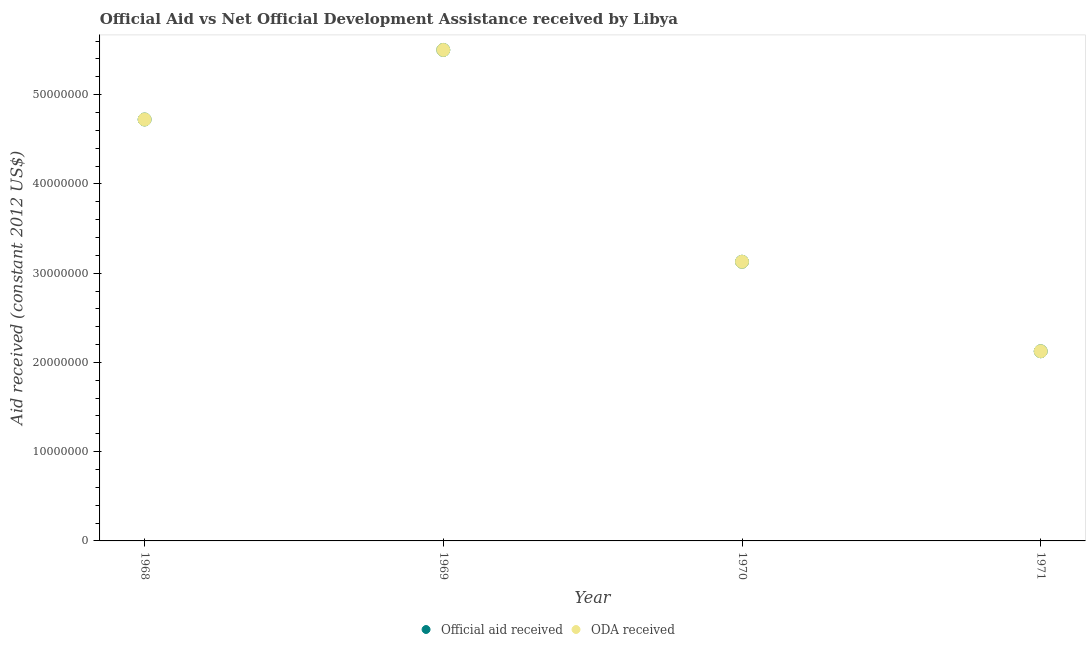How many different coloured dotlines are there?
Your answer should be very brief. 2. What is the official aid received in 1969?
Provide a short and direct response. 5.50e+07. Across all years, what is the maximum official aid received?
Make the answer very short. 5.50e+07. Across all years, what is the minimum official aid received?
Ensure brevity in your answer.  2.12e+07. In which year was the official aid received maximum?
Your response must be concise. 1969. What is the total official aid received in the graph?
Keep it short and to the point. 1.55e+08. What is the difference between the official aid received in 1969 and that in 1970?
Make the answer very short. 2.37e+07. What is the difference between the official aid received in 1968 and the oda received in 1971?
Give a very brief answer. 2.60e+07. What is the average oda received per year?
Provide a short and direct response. 3.87e+07. In the year 1968, what is the difference between the oda received and official aid received?
Offer a terse response. 0. What is the ratio of the oda received in 1968 to that in 1969?
Make the answer very short. 0.86. What is the difference between the highest and the second highest official aid received?
Offer a very short reply. 7.79e+06. What is the difference between the highest and the lowest oda received?
Provide a succinct answer. 3.38e+07. Is the sum of the official aid received in 1970 and 1971 greater than the maximum oda received across all years?
Provide a succinct answer. No. Is the official aid received strictly greater than the oda received over the years?
Offer a terse response. No. How many dotlines are there?
Keep it short and to the point. 2. Does the graph contain any zero values?
Offer a terse response. No. Where does the legend appear in the graph?
Keep it short and to the point. Bottom center. What is the title of the graph?
Offer a very short reply. Official Aid vs Net Official Development Assistance received by Libya . Does "Pregnant women" appear as one of the legend labels in the graph?
Your answer should be compact. No. What is the label or title of the Y-axis?
Provide a short and direct response. Aid received (constant 2012 US$). What is the Aid received (constant 2012 US$) in Official aid received in 1968?
Give a very brief answer. 4.72e+07. What is the Aid received (constant 2012 US$) of ODA received in 1968?
Offer a terse response. 4.72e+07. What is the Aid received (constant 2012 US$) in Official aid received in 1969?
Provide a short and direct response. 5.50e+07. What is the Aid received (constant 2012 US$) in ODA received in 1969?
Keep it short and to the point. 5.50e+07. What is the Aid received (constant 2012 US$) of Official aid received in 1970?
Provide a succinct answer. 3.13e+07. What is the Aid received (constant 2012 US$) in ODA received in 1970?
Your response must be concise. 3.13e+07. What is the Aid received (constant 2012 US$) in Official aid received in 1971?
Offer a very short reply. 2.12e+07. What is the Aid received (constant 2012 US$) of ODA received in 1971?
Your answer should be compact. 2.12e+07. Across all years, what is the maximum Aid received (constant 2012 US$) in Official aid received?
Your response must be concise. 5.50e+07. Across all years, what is the maximum Aid received (constant 2012 US$) of ODA received?
Make the answer very short. 5.50e+07. Across all years, what is the minimum Aid received (constant 2012 US$) of Official aid received?
Offer a very short reply. 2.12e+07. Across all years, what is the minimum Aid received (constant 2012 US$) of ODA received?
Offer a very short reply. 2.12e+07. What is the total Aid received (constant 2012 US$) of Official aid received in the graph?
Provide a succinct answer. 1.55e+08. What is the total Aid received (constant 2012 US$) of ODA received in the graph?
Your answer should be compact. 1.55e+08. What is the difference between the Aid received (constant 2012 US$) in Official aid received in 1968 and that in 1969?
Your answer should be compact. -7.79e+06. What is the difference between the Aid received (constant 2012 US$) of ODA received in 1968 and that in 1969?
Give a very brief answer. -7.79e+06. What is the difference between the Aid received (constant 2012 US$) of Official aid received in 1968 and that in 1970?
Your answer should be compact. 1.59e+07. What is the difference between the Aid received (constant 2012 US$) of ODA received in 1968 and that in 1970?
Offer a terse response. 1.59e+07. What is the difference between the Aid received (constant 2012 US$) of Official aid received in 1968 and that in 1971?
Keep it short and to the point. 2.60e+07. What is the difference between the Aid received (constant 2012 US$) of ODA received in 1968 and that in 1971?
Keep it short and to the point. 2.60e+07. What is the difference between the Aid received (constant 2012 US$) in Official aid received in 1969 and that in 1970?
Your answer should be compact. 2.37e+07. What is the difference between the Aid received (constant 2012 US$) of ODA received in 1969 and that in 1970?
Your answer should be very brief. 2.37e+07. What is the difference between the Aid received (constant 2012 US$) of Official aid received in 1969 and that in 1971?
Give a very brief answer. 3.38e+07. What is the difference between the Aid received (constant 2012 US$) in ODA received in 1969 and that in 1971?
Offer a very short reply. 3.38e+07. What is the difference between the Aid received (constant 2012 US$) in Official aid received in 1970 and that in 1971?
Offer a very short reply. 1.00e+07. What is the difference between the Aid received (constant 2012 US$) in ODA received in 1970 and that in 1971?
Ensure brevity in your answer.  1.00e+07. What is the difference between the Aid received (constant 2012 US$) of Official aid received in 1968 and the Aid received (constant 2012 US$) of ODA received in 1969?
Give a very brief answer. -7.79e+06. What is the difference between the Aid received (constant 2012 US$) of Official aid received in 1968 and the Aid received (constant 2012 US$) of ODA received in 1970?
Provide a succinct answer. 1.59e+07. What is the difference between the Aid received (constant 2012 US$) in Official aid received in 1968 and the Aid received (constant 2012 US$) in ODA received in 1971?
Offer a very short reply. 2.60e+07. What is the difference between the Aid received (constant 2012 US$) in Official aid received in 1969 and the Aid received (constant 2012 US$) in ODA received in 1970?
Ensure brevity in your answer.  2.37e+07. What is the difference between the Aid received (constant 2012 US$) of Official aid received in 1969 and the Aid received (constant 2012 US$) of ODA received in 1971?
Your response must be concise. 3.38e+07. What is the difference between the Aid received (constant 2012 US$) in Official aid received in 1970 and the Aid received (constant 2012 US$) in ODA received in 1971?
Make the answer very short. 1.00e+07. What is the average Aid received (constant 2012 US$) in Official aid received per year?
Your answer should be compact. 3.87e+07. What is the average Aid received (constant 2012 US$) in ODA received per year?
Offer a terse response. 3.87e+07. In the year 1968, what is the difference between the Aid received (constant 2012 US$) of Official aid received and Aid received (constant 2012 US$) of ODA received?
Your response must be concise. 0. What is the ratio of the Aid received (constant 2012 US$) of Official aid received in 1968 to that in 1969?
Make the answer very short. 0.86. What is the ratio of the Aid received (constant 2012 US$) of ODA received in 1968 to that in 1969?
Keep it short and to the point. 0.86. What is the ratio of the Aid received (constant 2012 US$) in Official aid received in 1968 to that in 1970?
Offer a terse response. 1.51. What is the ratio of the Aid received (constant 2012 US$) of ODA received in 1968 to that in 1970?
Offer a terse response. 1.51. What is the ratio of the Aid received (constant 2012 US$) of Official aid received in 1968 to that in 1971?
Offer a very short reply. 2.22. What is the ratio of the Aid received (constant 2012 US$) of ODA received in 1968 to that in 1971?
Your answer should be compact. 2.22. What is the ratio of the Aid received (constant 2012 US$) in Official aid received in 1969 to that in 1970?
Your response must be concise. 1.76. What is the ratio of the Aid received (constant 2012 US$) of ODA received in 1969 to that in 1970?
Make the answer very short. 1.76. What is the ratio of the Aid received (constant 2012 US$) in Official aid received in 1969 to that in 1971?
Your response must be concise. 2.59. What is the ratio of the Aid received (constant 2012 US$) of ODA received in 1969 to that in 1971?
Ensure brevity in your answer.  2.59. What is the ratio of the Aid received (constant 2012 US$) of Official aid received in 1970 to that in 1971?
Offer a very short reply. 1.47. What is the ratio of the Aid received (constant 2012 US$) in ODA received in 1970 to that in 1971?
Provide a succinct answer. 1.47. What is the difference between the highest and the second highest Aid received (constant 2012 US$) in Official aid received?
Your answer should be very brief. 7.79e+06. What is the difference between the highest and the second highest Aid received (constant 2012 US$) in ODA received?
Give a very brief answer. 7.79e+06. What is the difference between the highest and the lowest Aid received (constant 2012 US$) in Official aid received?
Provide a succinct answer. 3.38e+07. What is the difference between the highest and the lowest Aid received (constant 2012 US$) of ODA received?
Provide a short and direct response. 3.38e+07. 